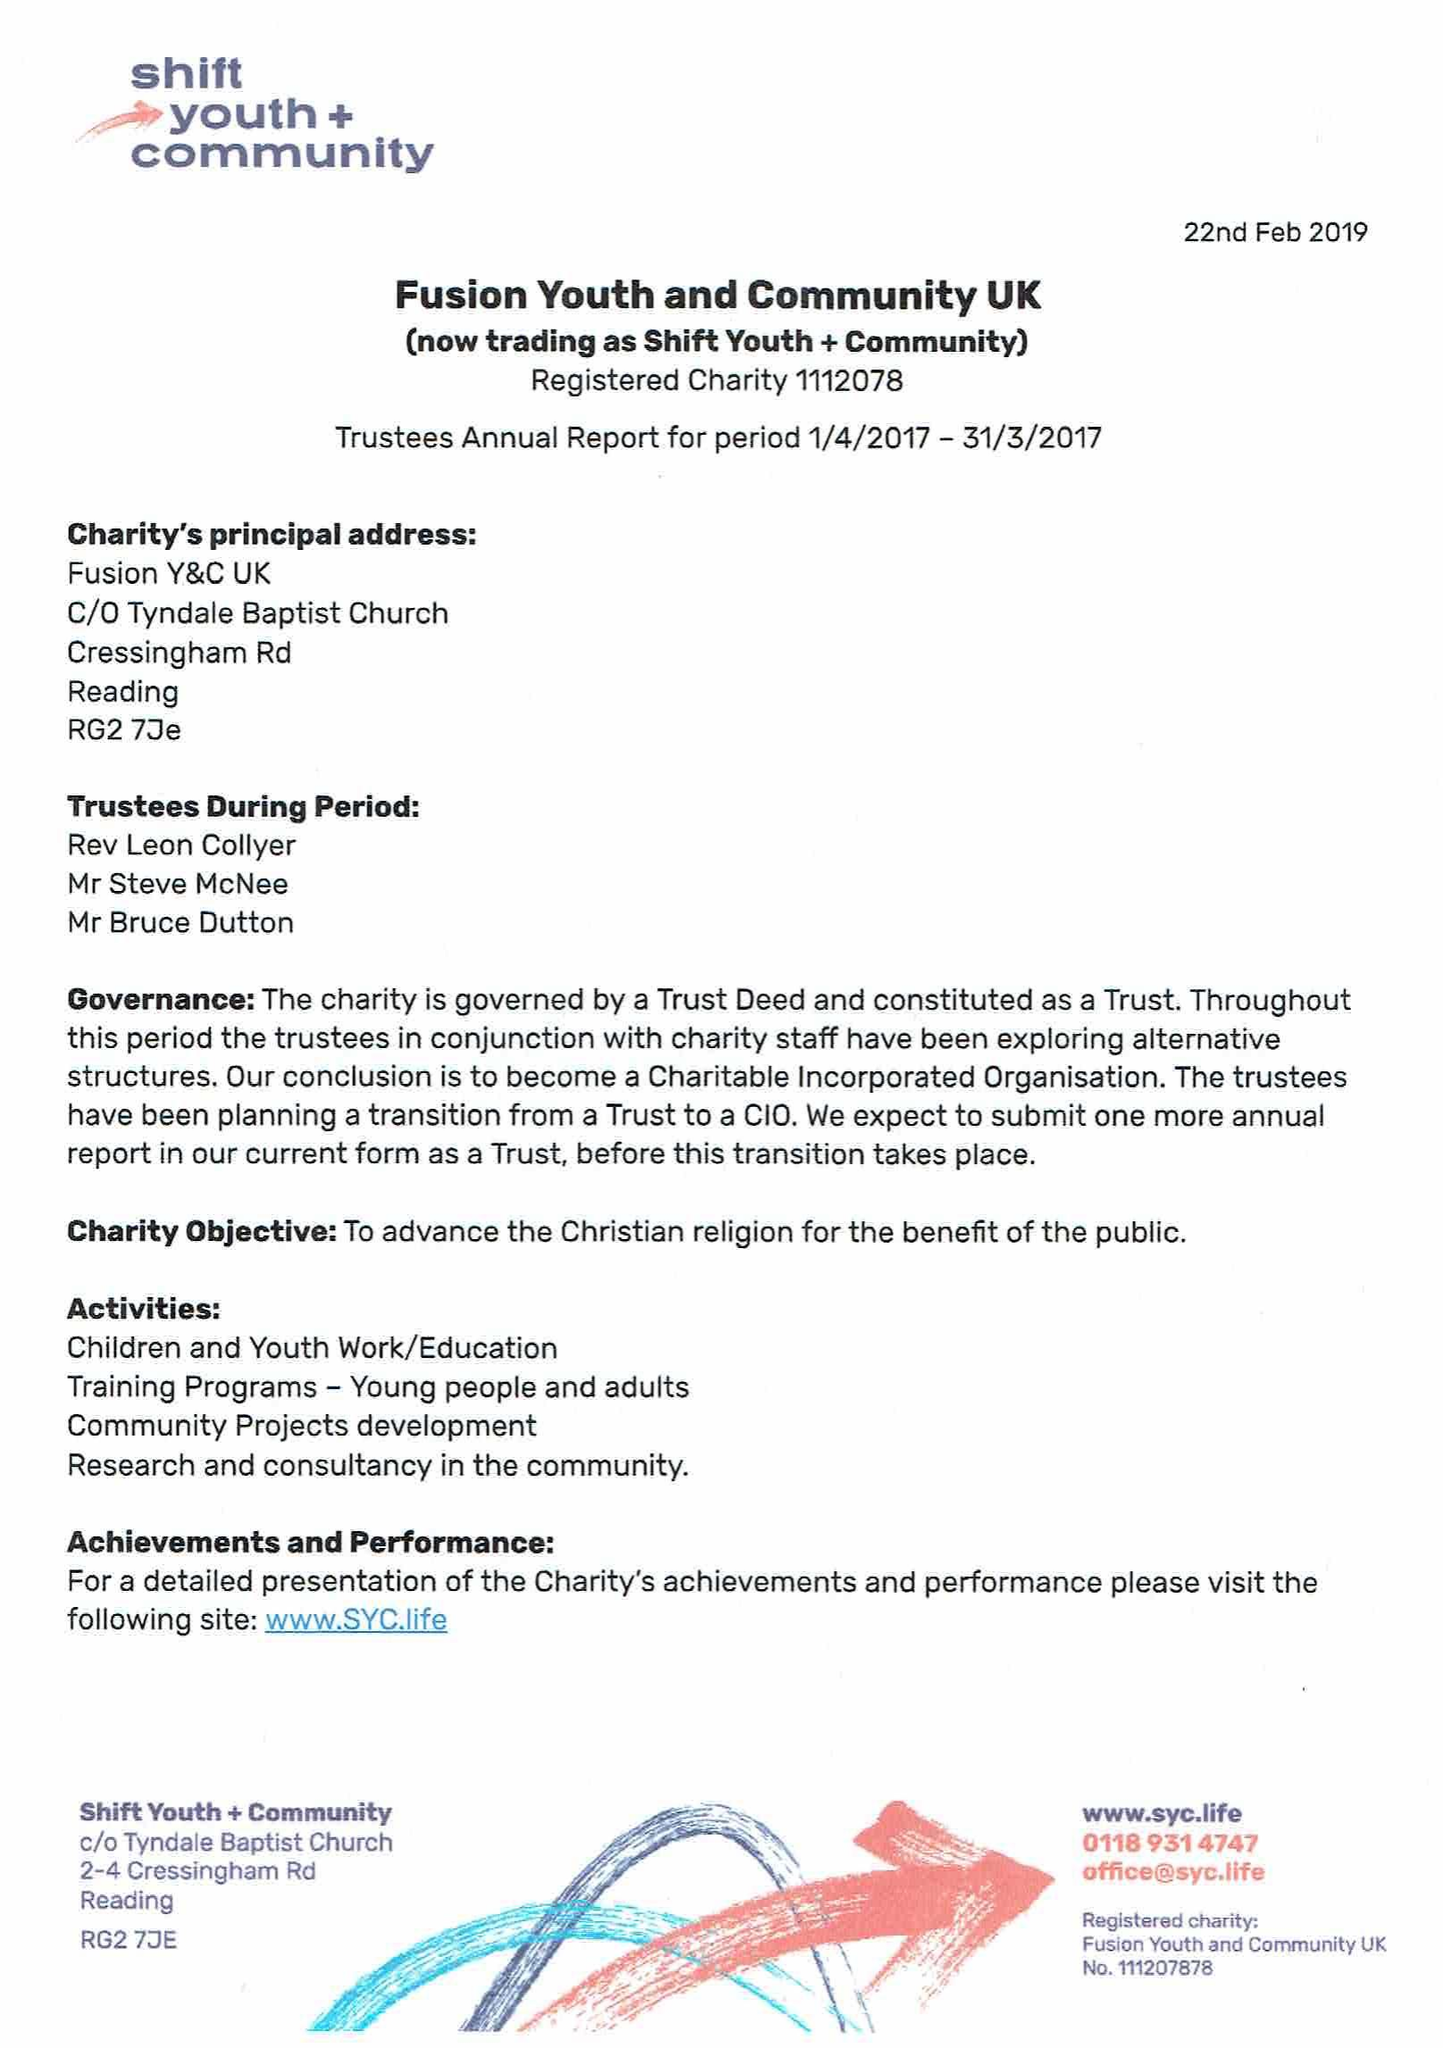What is the value for the address__street_line?
Answer the question using a single word or phrase. None 